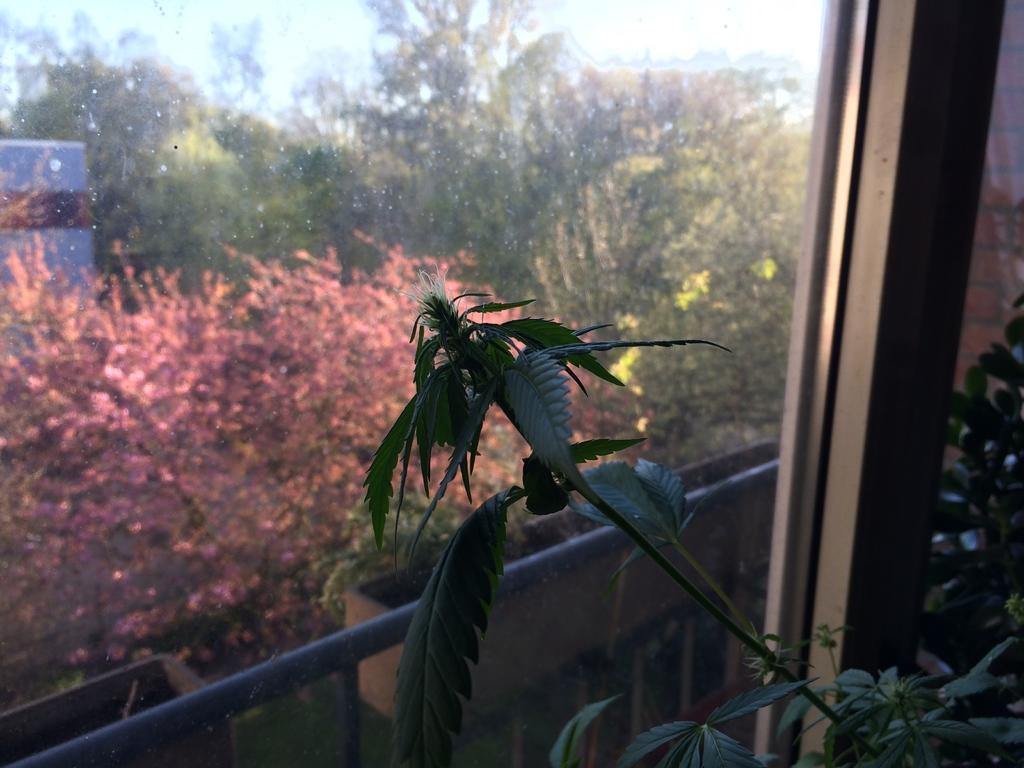What type of door is visible in the image? There is a glass door in the image. What can be seen inside the room with the glass door? Plants are visible inside the room. What is visible outside the glass door? Trees are visible outside the glass door. What part of the natural environment is visible in the image? The sky is visible in the image. What type of lift can be seen in the image? There is no lift present in the image. How many snails are visible on the plants in the image? There are no snails visible on the plants in the image. 